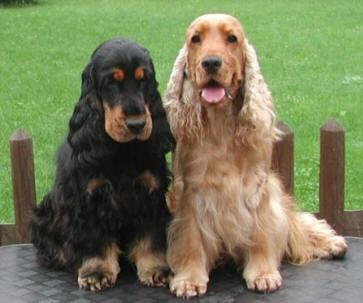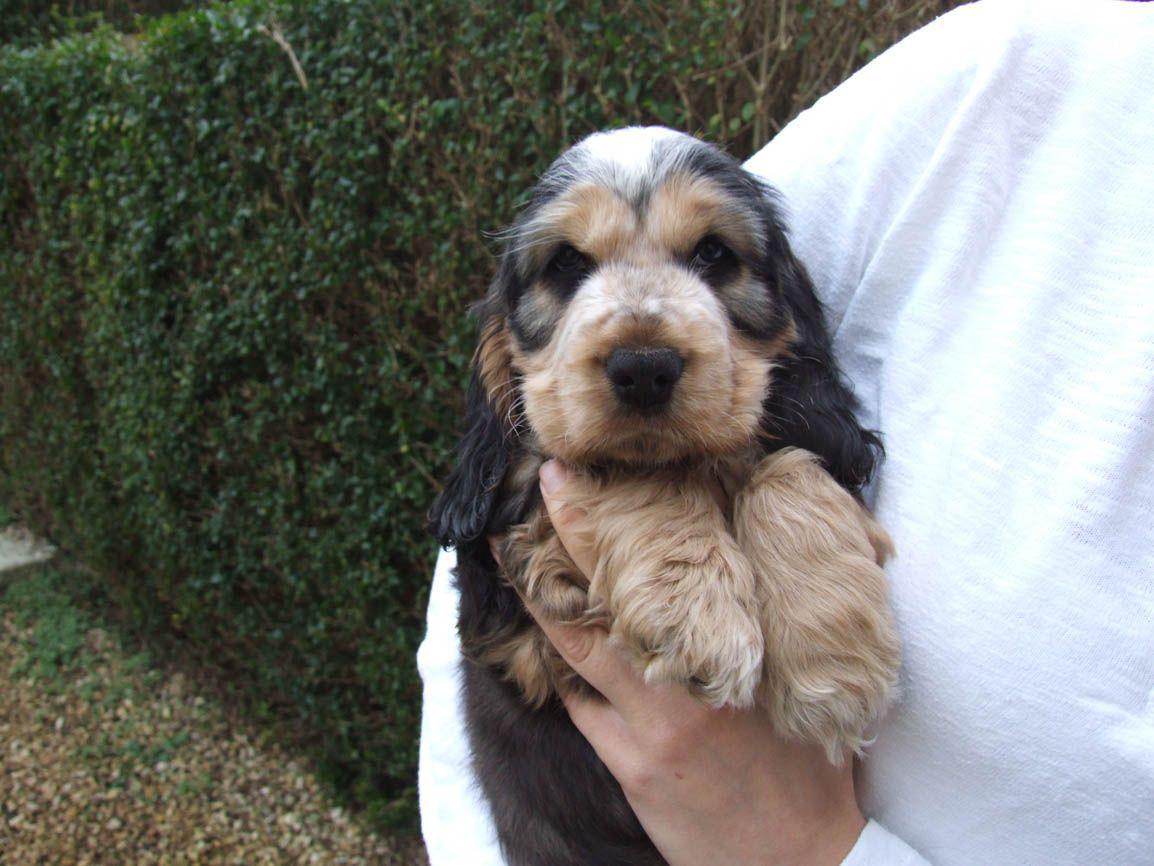The first image is the image on the left, the second image is the image on the right. Considering the images on both sides, is "An image contains two dogs side by side." valid? Answer yes or no. Yes. The first image is the image on the left, the second image is the image on the right. Evaluate the accuracy of this statement regarding the images: "A human is holding a dog in one of the images.". Is it true? Answer yes or no. Yes. 